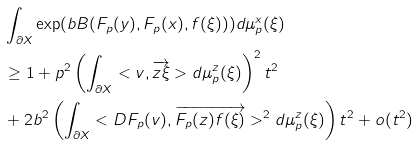<formula> <loc_0><loc_0><loc_500><loc_500>& \int _ { \partial X } \exp ( b B ( F _ { p } ( y ) , F _ { p } ( x ) , f ( \xi ) ) ) d \mu ^ { x } _ { p } ( \xi ) \\ & \geq 1 + p ^ { 2 } \left ( \int _ { \partial X } < v , \overrightarrow { z \xi } > d \mu ^ { z } _ { p } ( \xi ) \right ) ^ { 2 } t ^ { 2 } \\ & + 2 b ^ { 2 } \left ( \int _ { \partial X } < D F _ { p } ( v ) , \overrightarrow { F _ { p } ( z ) f ( \xi ) } > ^ { 2 } d \mu ^ { z } _ { p } ( \xi ) \right ) t ^ { 2 } + o ( t ^ { 2 } ) \\</formula> 